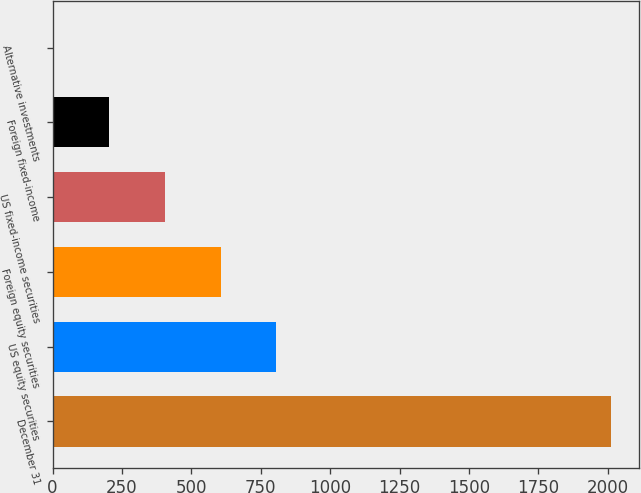<chart> <loc_0><loc_0><loc_500><loc_500><bar_chart><fcel>December 31<fcel>US equity securities<fcel>Foreign equity securities<fcel>US fixed-income securities<fcel>Foreign fixed-income<fcel>Alternative investments<nl><fcel>2013<fcel>806.4<fcel>605.3<fcel>404.2<fcel>203.1<fcel>2<nl></chart> 